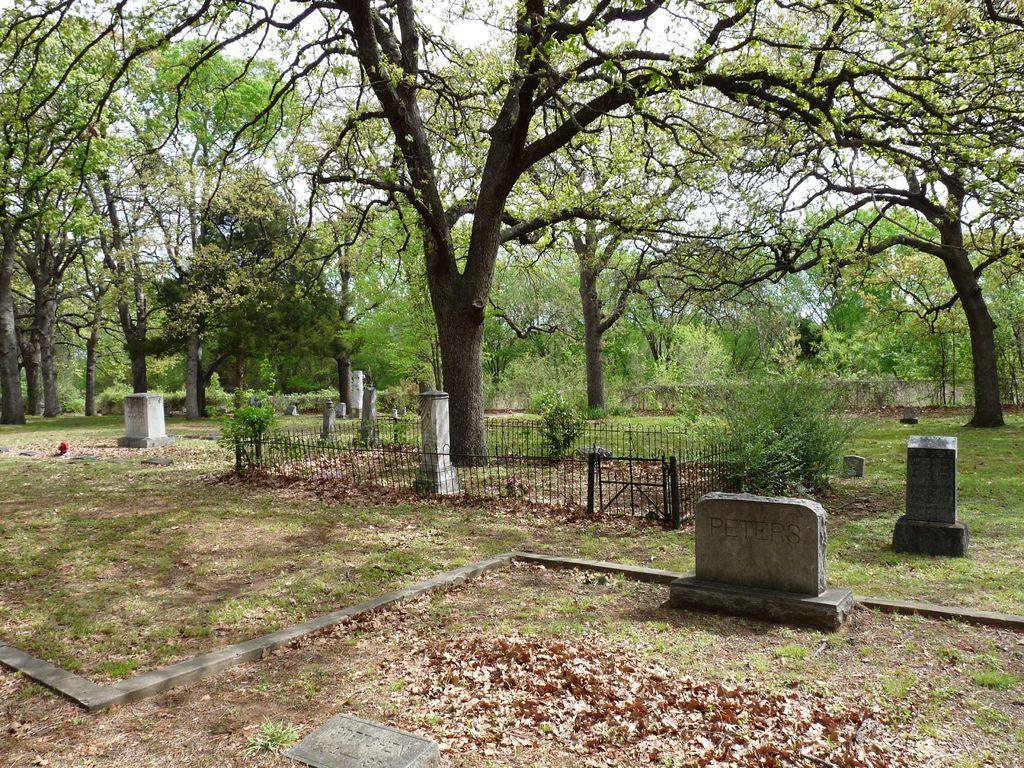Please provide a concise description of this image. There are graves, dry leaves, a fence, plants, trees and grass on the ground. In the background, there are trees and there is sky. 